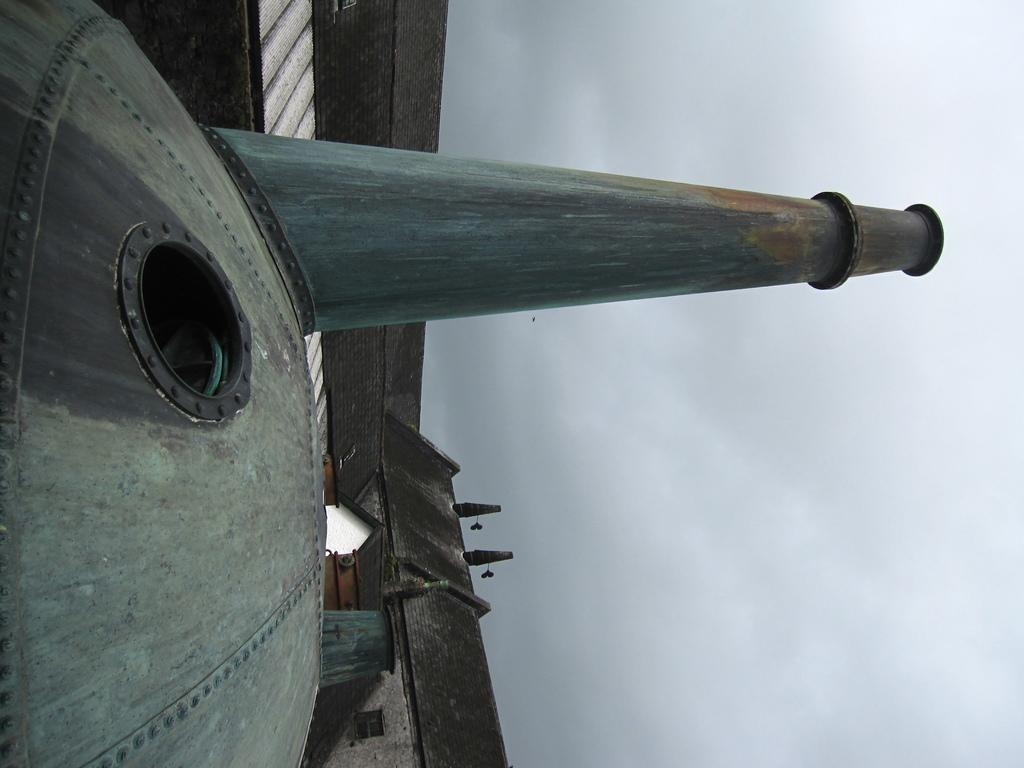What type of structure is in the image? There is a metallic chamber in the image. What feature can be seen on the metallic chamber? The metallic chamber has a pipe on it. What can be seen in the distance in the image? There are houses visible in the background of the image. What is visible above the houses in the image? The sky is visible in the background of the image, and clouds are present in the sky. What type of lettuce is being used to cover the metallic chamber in the image? There is no lettuce present in the image; it features a metallic chamber with a pipe and a background of houses and clouds. 